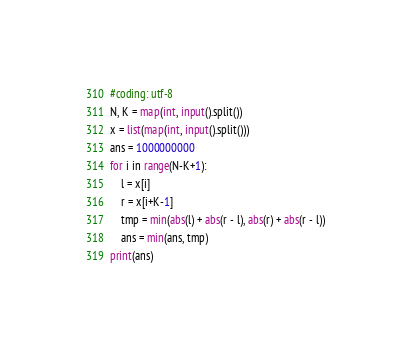Convert code to text. <code><loc_0><loc_0><loc_500><loc_500><_Python_>#coding: utf-8
N, K = map(int, input().split())
x = list(map(int, input().split()))
ans = 1000000000
for i in range(N-K+1):
    l = x[i]
    r = x[i+K-1]
    tmp = min(abs(l) + abs(r - l), abs(r) + abs(r - l))
    ans = min(ans, tmp)
print(ans)</code> 